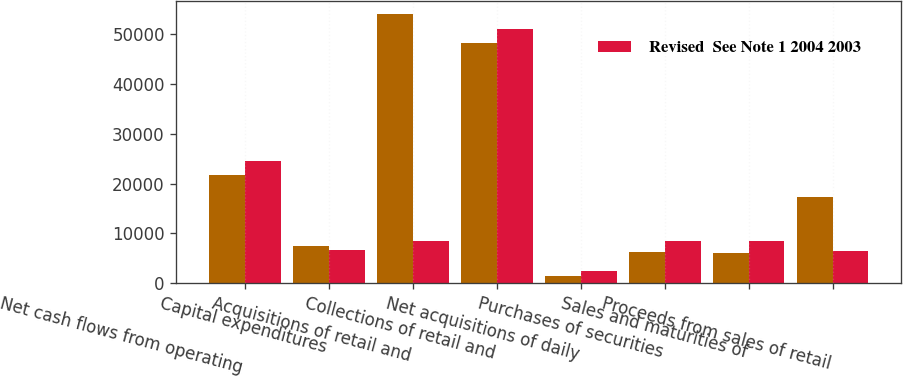<chart> <loc_0><loc_0><loc_500><loc_500><stacked_bar_chart><ecel><fcel>Net cash flows from operating<fcel>Capital expenditures<fcel>Acquisitions of retail and<fcel>Collections of retail and<fcel>Net acquisitions of daily<fcel>Purchases of securities<fcel>Sales and maturities of<fcel>Proceeds from sales of retail<nl><fcel>nan<fcel>21674<fcel>7517<fcel>54024<fcel>48238<fcel>1552<fcel>6278<fcel>6154<fcel>17288<nl><fcel>Revised  See Note 1 2004 2003<fcel>24562<fcel>6738<fcel>8414<fcel>51024<fcel>2492<fcel>8470<fcel>8414<fcel>6481<nl></chart> 